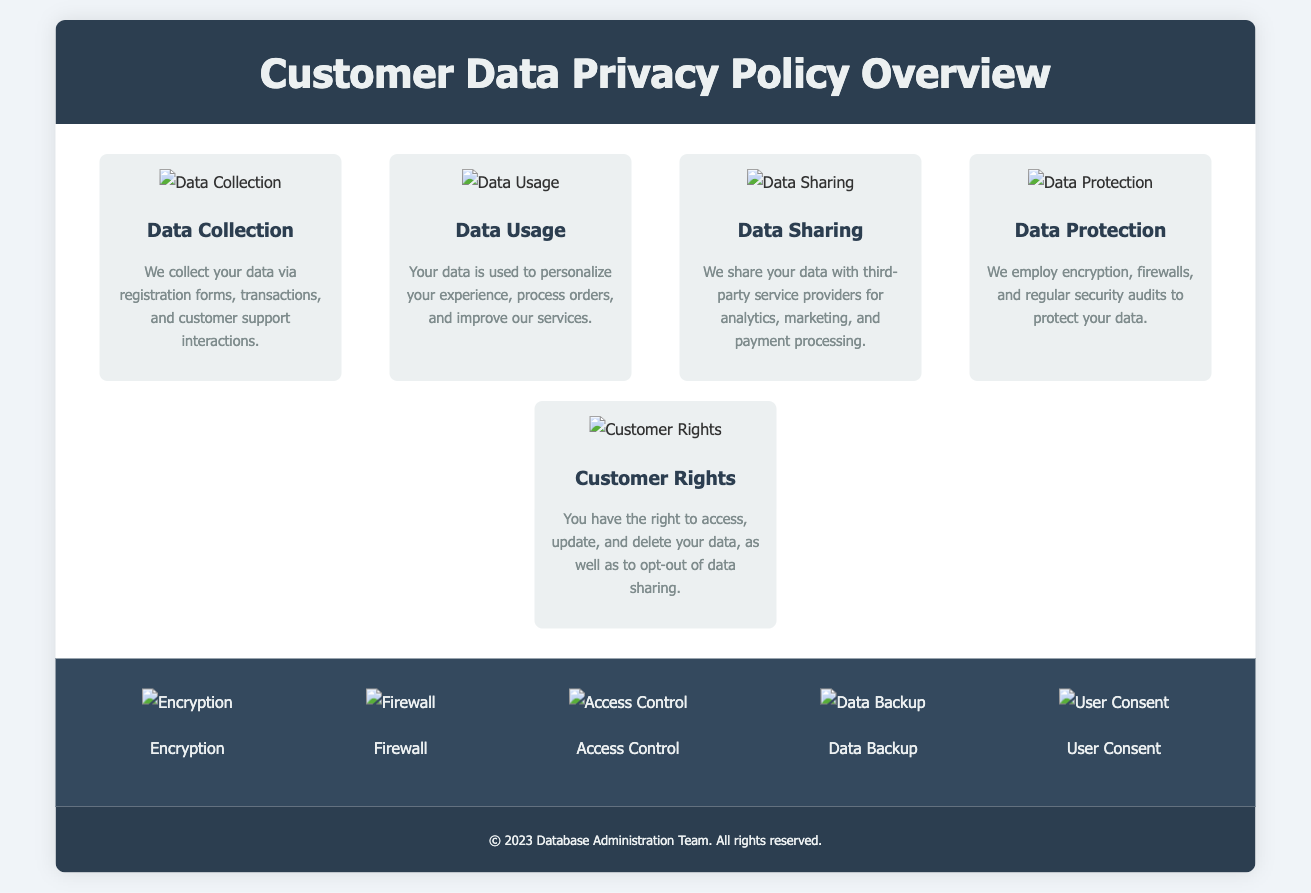What are the methods of data collection? The document lists registration forms, transactions, and customer support interactions as methods for data collection.
Answer: registration forms, transactions, customer support interactions How is customer data used? The document states that customer data is used to personalize experiences, process orders, and improve services.
Answer: personalize experiences, process orders, improve services What right do customers have regarding their data? The document mentions that customers have the right to access, update, and delete their data, and opt-out of data sharing.
Answer: access, update, delete, opt-out What is employed to protect customer data? The document specifies the use of encryption, firewalls, and regular security audits for data protection.
Answer: encryption, firewalls, security audits What type of service providers is customer data shared with? According to the document, customer data is shared with third-party service providers for analytics, marketing, and payment processing.
Answer: third-party service providers Which icon represents data protection? The infographic contains a section with an icon specifically representing data protection.
Answer: data_protection_icon How many sections are there in the infographic? The document outlines five sections in the infographic that cover different aspects of customer data privacy.
Answer: five sections What is the background color of the footer? The footer background color is specified as dark blue (#2c3e50) in the document.
Answer: dark blue What is the primary purpose of this document? The purpose of the document is to provide an overview of the Customer Data Privacy Policy.
Answer: overview of Customer Data Privacy Policy 